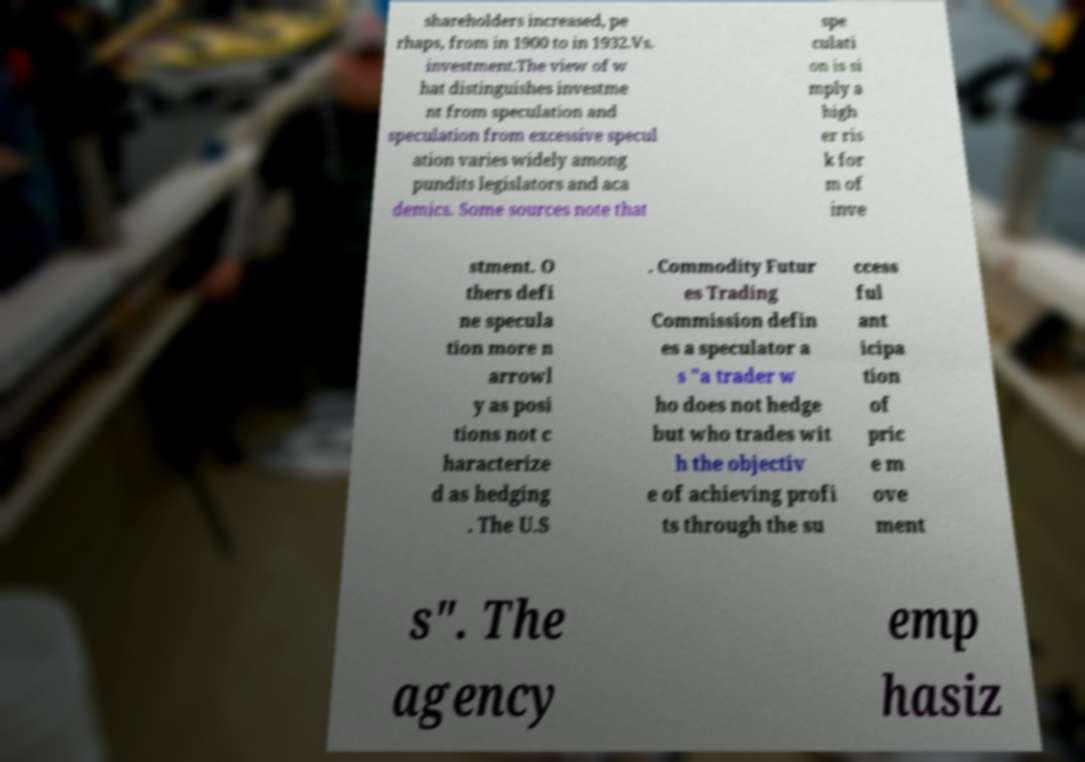Please identify and transcribe the text found in this image. shareholders increased, pe rhaps, from in 1900 to in 1932.Vs. investment.The view of w hat distinguishes investme nt from speculation and speculation from excessive specul ation varies widely among pundits legislators and aca demics. Some sources note that spe culati on is si mply a high er ris k for m of inve stment. O thers defi ne specula tion more n arrowl y as posi tions not c haracterize d as hedging . The U.S . Commodity Futur es Trading Commission defin es a speculator a s "a trader w ho does not hedge but who trades wit h the objectiv e of achieving profi ts through the su ccess ful ant icipa tion of pric e m ove ment s". The agency emp hasiz 